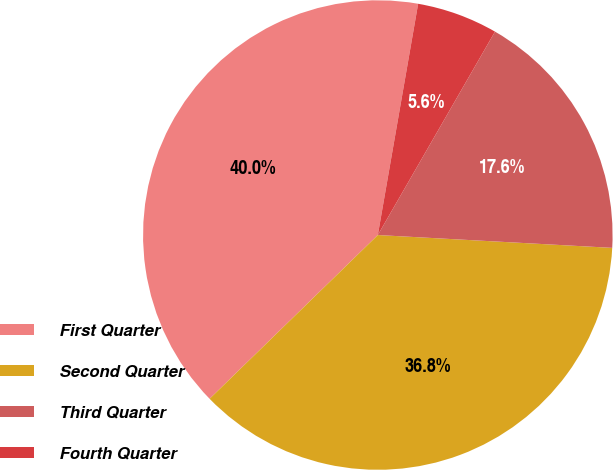Convert chart. <chart><loc_0><loc_0><loc_500><loc_500><pie_chart><fcel>First Quarter<fcel>Second Quarter<fcel>Third Quarter<fcel>Fourth Quarter<nl><fcel>40.03%<fcel>36.84%<fcel>17.55%<fcel>5.57%<nl></chart> 